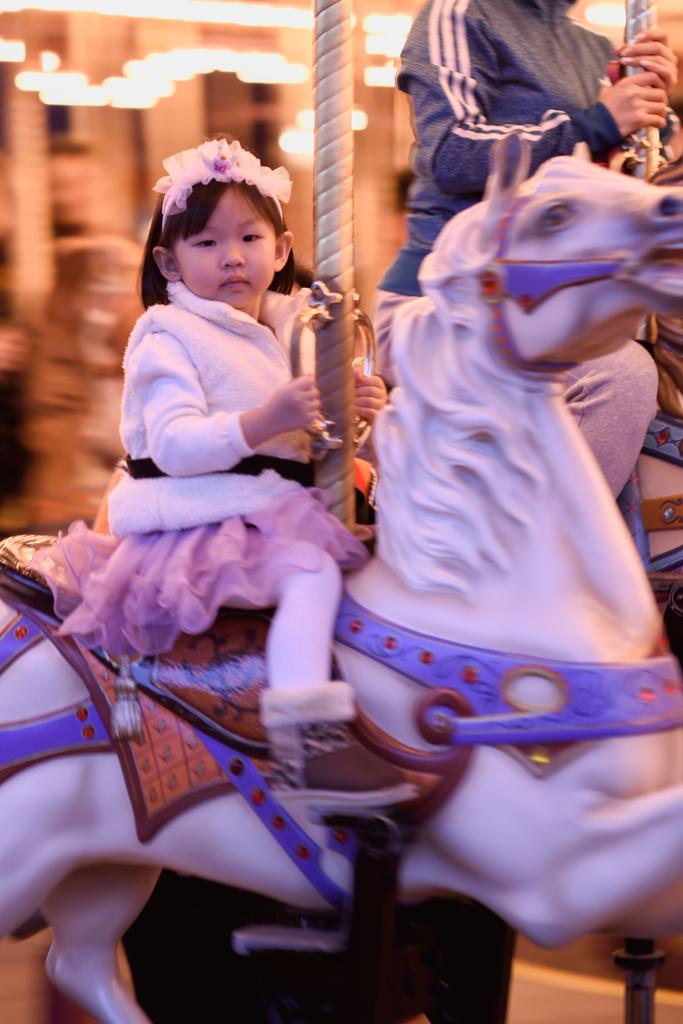Who or what is the main subject in the image? There is a child in the image. What is the child doing in the image? The child is sitting on a toy horse. Can you describe the setting or background of the image? There is another person in the background of the image. What type of beast can be seen grazing in the background of the image? There is no beast or grazing activity present in the image; it features a child sitting on a toy horse with another person in the background. 